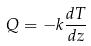<formula> <loc_0><loc_0><loc_500><loc_500>Q = - k \frac { d T } { d z }</formula> 